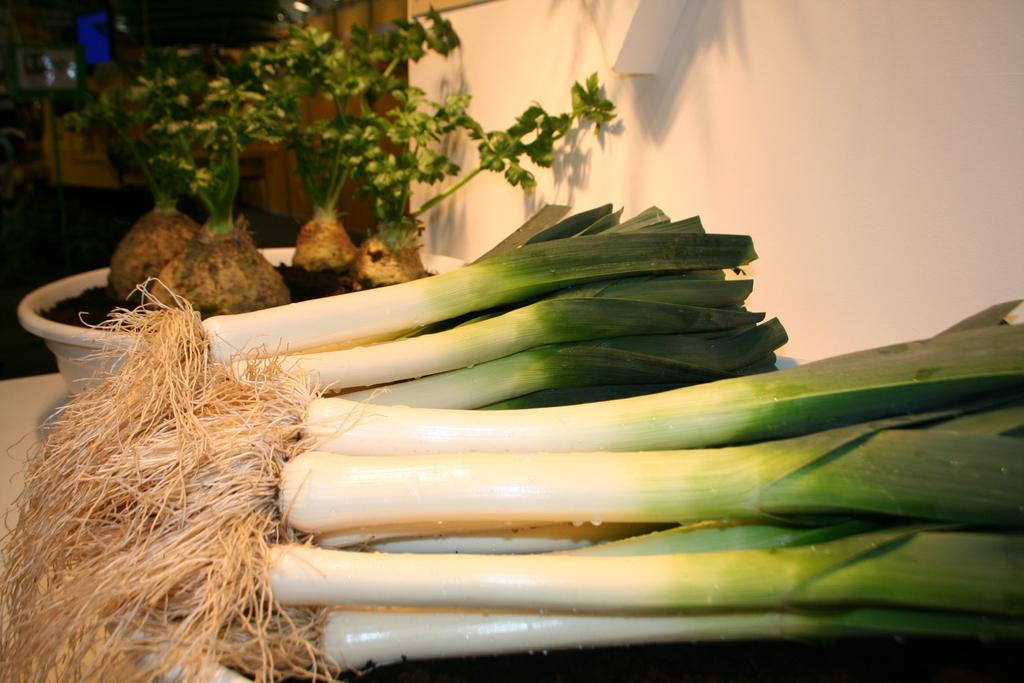What is written at the bottom of the image? There are weeks written at the bottom of the image. What type of vegetation is on the left side of the image? There are plants on the left side of the image. What is the structure on the right side of the image? There is a wall on the right side of the image. What color is the curtain hanging in front of the wall in the image? There is no curtain present in the image; it only features weeks, plants, and a wall. What type of operation is being performed on the plants in the image? There is no operation being performed on the plants in the image; they are simply depicted as part of the scene. 